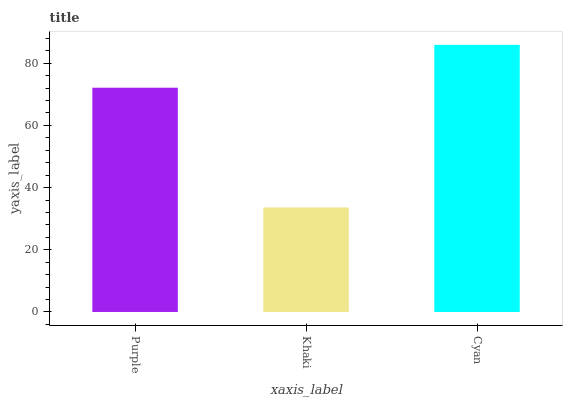Is Khaki the minimum?
Answer yes or no. Yes. Is Cyan the maximum?
Answer yes or no. Yes. Is Cyan the minimum?
Answer yes or no. No. Is Khaki the maximum?
Answer yes or no. No. Is Cyan greater than Khaki?
Answer yes or no. Yes. Is Khaki less than Cyan?
Answer yes or no. Yes. Is Khaki greater than Cyan?
Answer yes or no. No. Is Cyan less than Khaki?
Answer yes or no. No. Is Purple the high median?
Answer yes or no. Yes. Is Purple the low median?
Answer yes or no. Yes. Is Cyan the high median?
Answer yes or no. No. Is Cyan the low median?
Answer yes or no. No. 